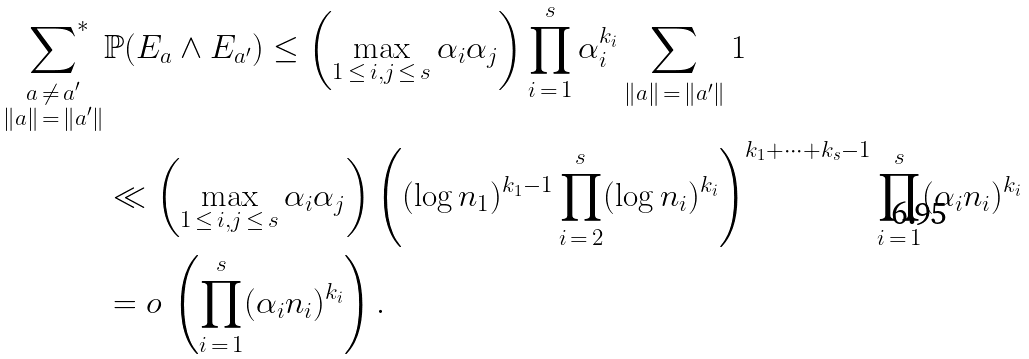<formula> <loc_0><loc_0><loc_500><loc_500>\sideset { \, } { ^ { * } } \sum _ { \substack { a \, \neq \, a ^ { \prime } \\ \| a \| \, = \, \| a ^ { \prime } \| } } & \mathbb { P } ( E _ { a } \wedge E _ { a ^ { \prime } } ) \leq \left ( \max _ { 1 \, \leq \, i , j \, \leq \, s } \alpha _ { i } \alpha _ { j } \right ) \prod _ { i \, = \, 1 } ^ { s } \alpha _ { i } ^ { k _ { i } } \sum _ { \| a \| \, = \, \| a ^ { \prime } \| } 1 \\ & \ll \left ( \max _ { 1 \, \leq \, i , j \, \leq \, s } \alpha _ { i } \alpha _ { j } \right ) \left ( ( \log n _ { 1 } ) ^ { k _ { 1 } - 1 } \prod _ { i \, = \, 2 } ^ { s } ( \log n _ { i } ) ^ { k _ { i } } \right ) ^ { k _ { 1 } + \cdots + k _ { s } - 1 } \prod _ { i \, = \, 1 } ^ { s } ( \alpha _ { i } n _ { i } ) ^ { k _ { i } } \\ & = o \, \left ( \prod _ { i \, = \, 1 } ^ { s } ( \alpha _ { i } n _ { i } ) ^ { k _ { i } } \right ) .</formula> 